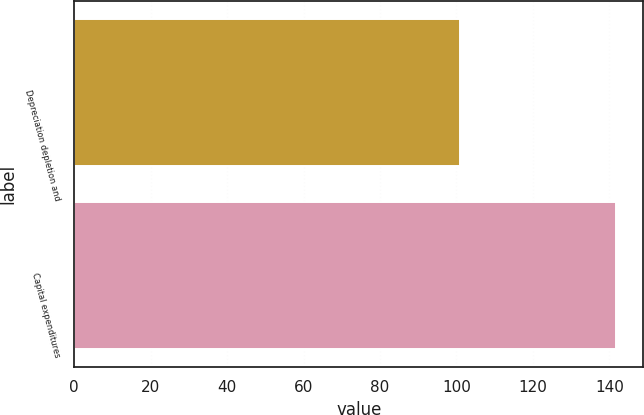Convert chart. <chart><loc_0><loc_0><loc_500><loc_500><bar_chart><fcel>Depreciation depletion and<fcel>Capital expenditures<nl><fcel>100.8<fcel>141.8<nl></chart> 